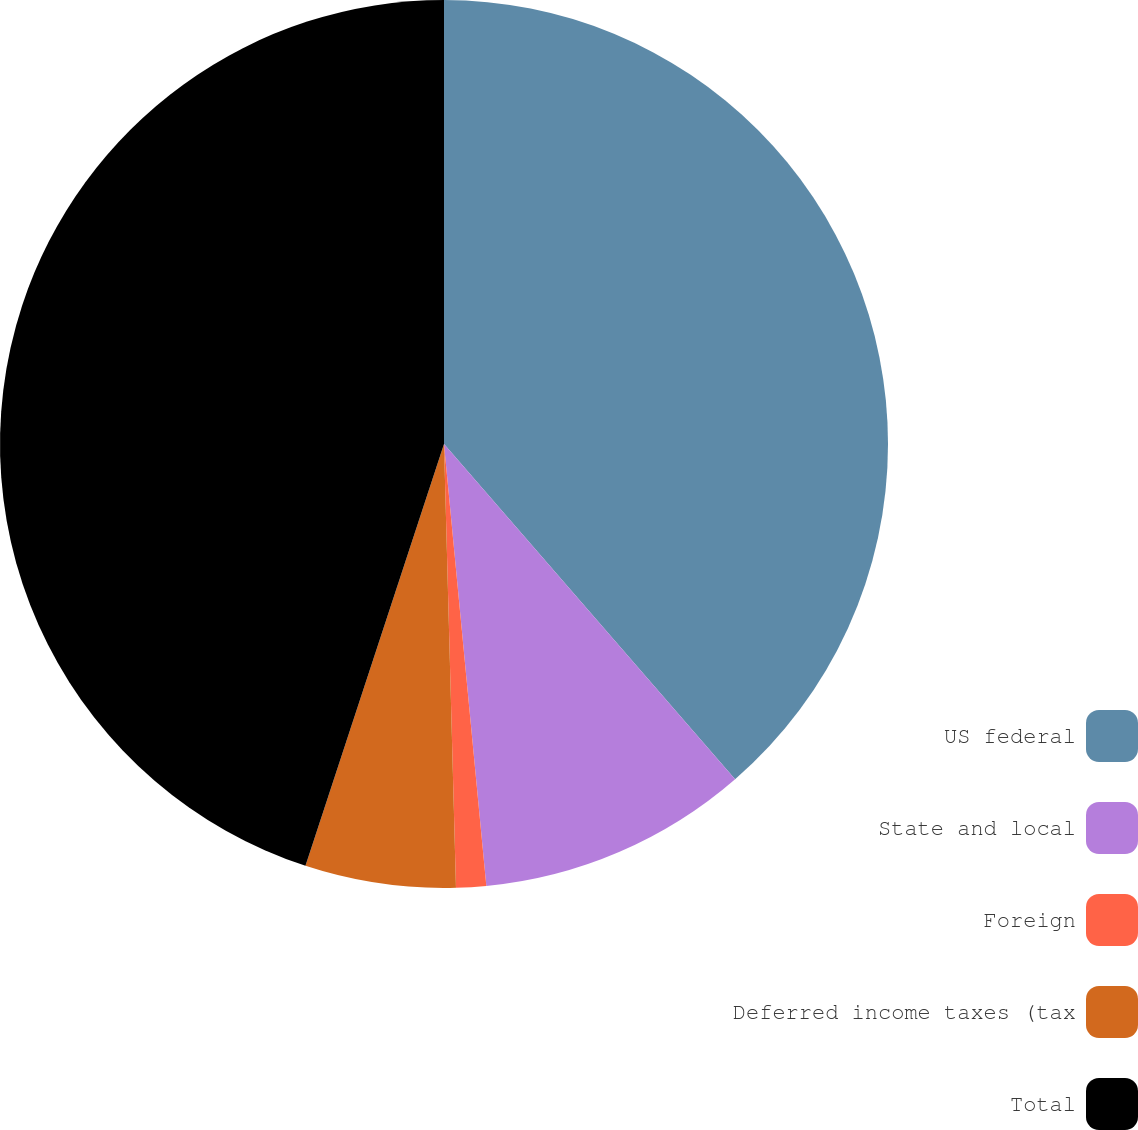Convert chart to OTSL. <chart><loc_0><loc_0><loc_500><loc_500><pie_chart><fcel>US federal<fcel>State and local<fcel>Foreign<fcel>Deferred income taxes (tax<fcel>Total<nl><fcel>38.62%<fcel>9.86%<fcel>1.09%<fcel>5.48%<fcel>44.95%<nl></chart> 